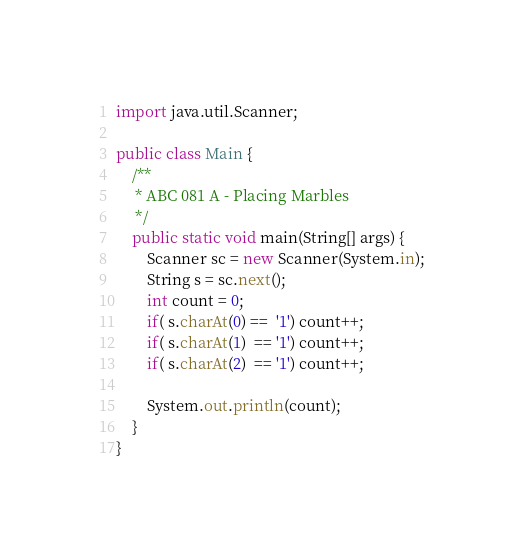Convert code to text. <code><loc_0><loc_0><loc_500><loc_500><_Java_>import java.util.Scanner;

public class Main {
    /**
     * ABC 081 A - Placing Marbles 
     */
    public static void main(String[] args) {
        Scanner sc = new Scanner(System.in);
        String s = sc.next();
        int count = 0;
        if( s.charAt(0) ==  '1') count++;
        if( s.charAt(1)  == '1') count++;
        if( s.charAt(2)  == '1') count++;
         
        System.out.println(count);
    }
}
</code> 